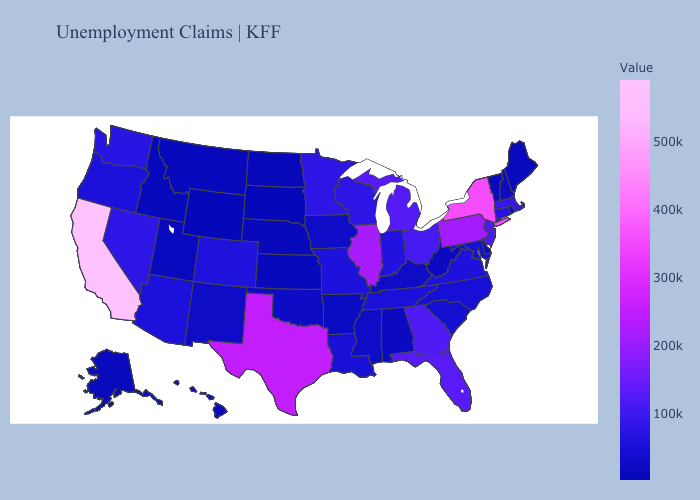Does Montana have a higher value than Pennsylvania?
Keep it brief. No. Among the states that border Wyoming , does Utah have the highest value?
Write a very short answer. No. Which states have the lowest value in the USA?
Quick response, please. South Dakota. Among the states that border South Carolina , which have the lowest value?
Give a very brief answer. North Carolina. Among the states that border Arkansas , which have the lowest value?
Quick response, please. Oklahoma. Is the legend a continuous bar?
Concise answer only. Yes. Does Wisconsin have a lower value than Illinois?
Short answer required. Yes. Which states have the lowest value in the Northeast?
Answer briefly. Vermont. Does Massachusetts have a lower value than Texas?
Short answer required. Yes. 